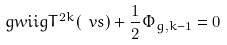<formula> <loc_0><loc_0><loc_500><loc_500>\ g w i i g { T ^ { 2 k } ( \ v s ) } + \frac { 1 } { 2 } \Phi _ { g , k - 1 } = 0</formula> 